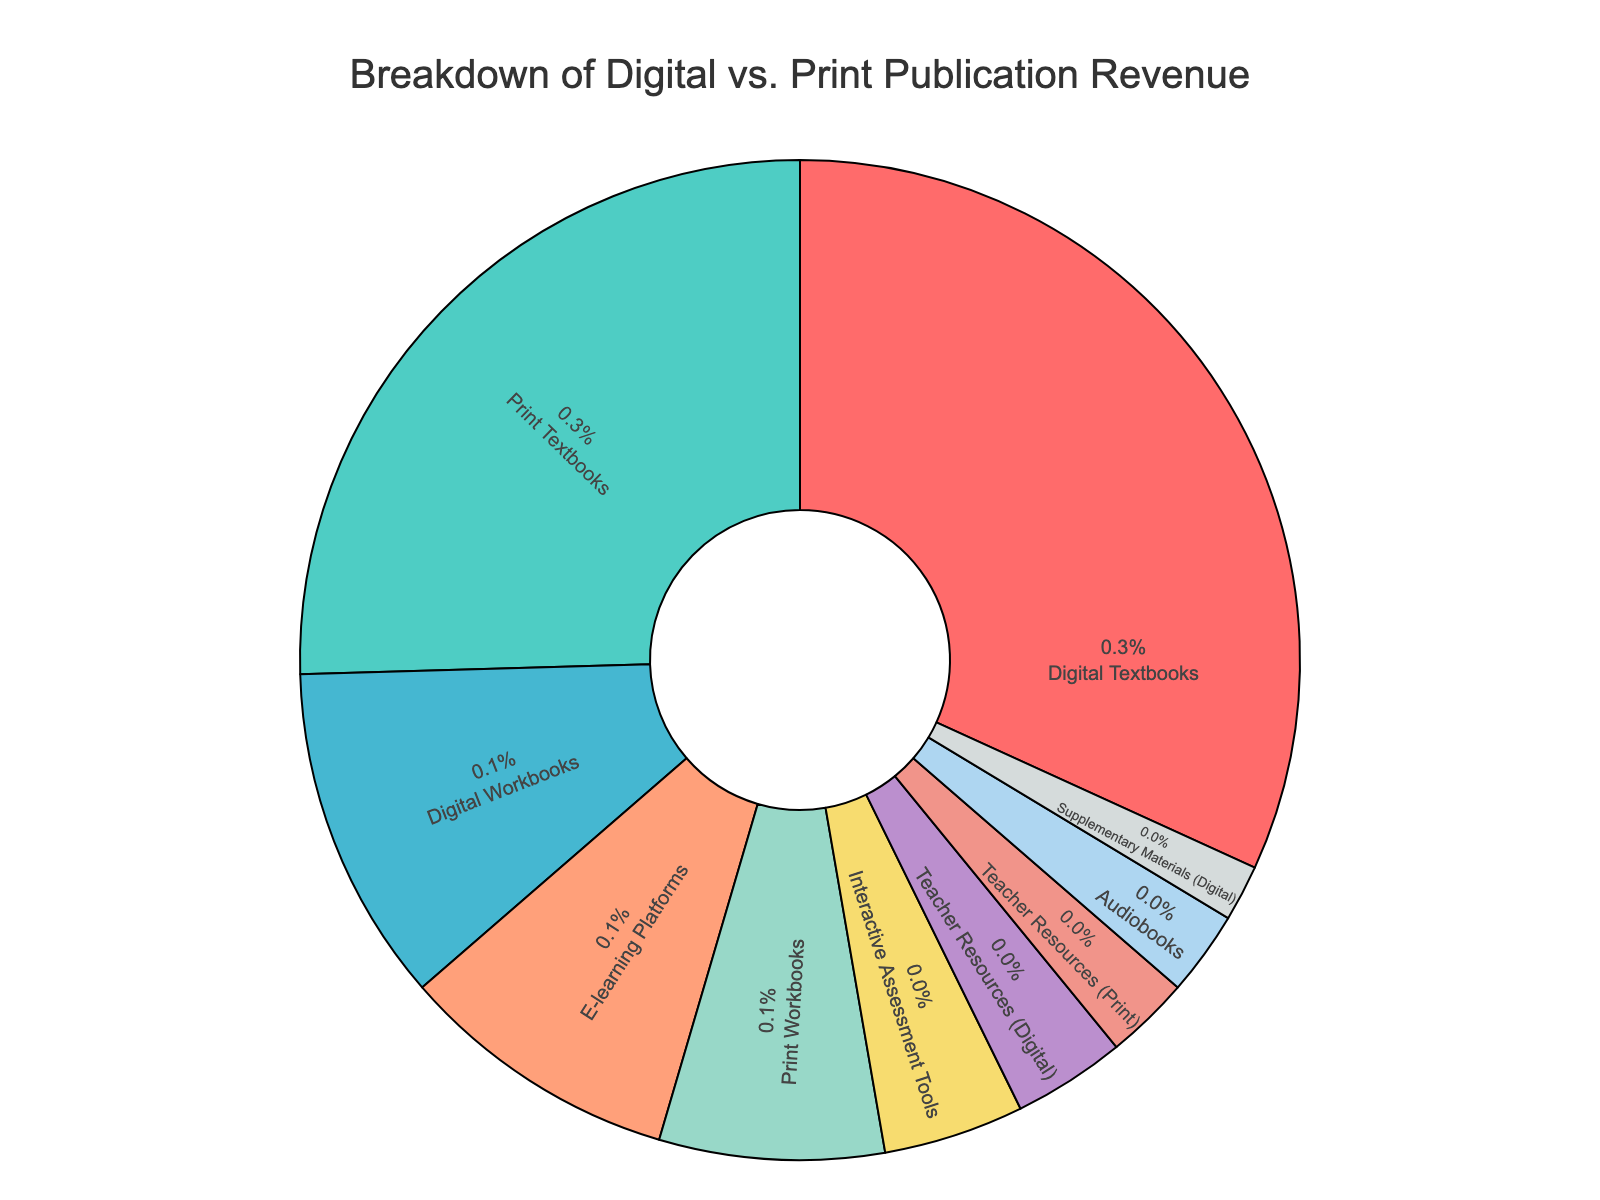what percentage of the revenue comes from digital textbooks? To find the percentage contribution from digital textbooks, look at the segment labeled "Digital Textbooks" in the pie chart. Let's see that this segment represents 35% of the total.
Answer: 35% Which revenue source contributes more, print textbooks or digital workbooks? Compare the percentage values from the segments labeled "Print Textbooks" and "Digital Workbooks." Print Textbooks contribute 28%, whereas Digital Workbooks contribute 12%. Therefore, print textbooks contribute more to the revenue.
Answer: Print Textbooks What is the combined revenue contribution of e-learning platforms and interactive assessment tools? Add the percentages of the segments labeled "E-learning Platforms" (10%) and "Interactive Assessment Tools" (5%). The combined contribution is 10% + 5% = 15%.
Answer: 15% Are there more revenue contributions from digital resources than print resources? Sum the percentages of digital resources: Digital Textbooks (35%), Digital Workbooks (12%), E-learning Platforms (10%), Interactive Assessment Tools (5%), Teacher Resources (Digital) (4%), Supplementary Materials (Digital) (2%) which equals 35% + 12% + 10% + 5% + 4% + 2% = 68%. Then sum the percentages of print resources: Print Textbooks (28%), Print Workbooks (8%), Teacher Resources (Print) (3%), which equals 28% + 8% + 3% = 39%. Since 68% > 39%, digital resources contribute more.
Answer: Yes Which digital source has the least contribution, and what is its percentage? Look at the segments representing digital sources and identify the one with the smallest percentage. "Supplementary Materials (Digital)" has the smallest contribution at 2%.
Answer: Supplementary Materials (Digital), 2% What is the difference in percentage between digital textbooks and print workbooks? Subtract the percentage of "Print Workbooks" (8%) from that of "Digital Textbooks" (35%). The difference is 35% - 8% = 27%.
Answer: 27% What percentage of the revenue comes from teacher resources (digital and print combined)? Add the percentages of the segments labeled "Teacher Resources (Digital)" (4%) and "Teacher Resources (Print)" (3%). The combined contribution is 4% + 3% = 7%.
Answer: 7% Which segment has the smallest percentage contribution, and what is that percentage? Identify the segment with the smallest slice in the pie chart. "Supplementary Materials (Digital)" has the smallest percentage at 2%.
Answer: Supplementary Materials (Digital), 2% 